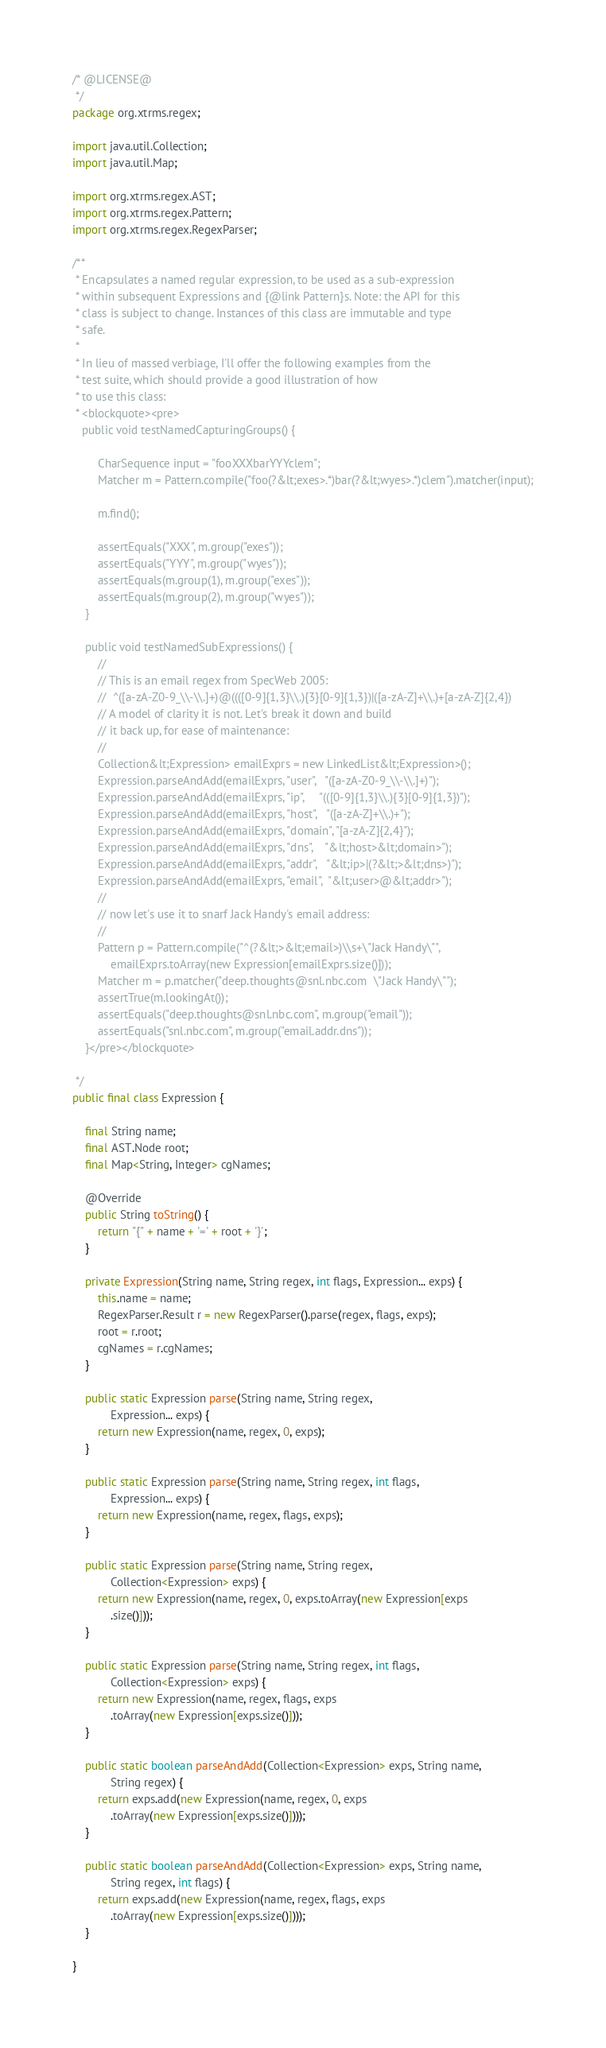Convert code to text. <code><loc_0><loc_0><loc_500><loc_500><_Java_>/* @LICENSE@  
 */
package org.xtrms.regex;

import java.util.Collection;
import java.util.Map;

import org.xtrms.regex.AST;
import org.xtrms.regex.Pattern;
import org.xtrms.regex.RegexParser;

/**
 * Encapsulates a named regular expression, to be used as a sub-expression
 * within subsequent Expressions and {@link Pattern}s. Note: the API for this
 * class is subject to change. Instances of this class are immutable and type
 * safe.
 * 
 * In lieu of massed verbiage, I'll offer the following examples from the 
 * test suite, which should provide a good illustration of how
 * to use this class:
 * <blockquote><pre>
   public void testNamedCapturingGroups() {
        
        CharSequence input = "fooXXXbarYYYclem";
        Matcher m = Pattern.compile("foo(?&lt;exes>.*)bar(?&lt;wyes>.*)clem").matcher(input);
        
        m.find();
        
        assertEquals("XXX", m.group("exes"));
        assertEquals("YYY", m.group("wyes"));
        assertEquals(m.group(1), m.group("exes"));
        assertEquals(m.group(2), m.group("wyes"));
    }
    
    public void testNamedSubExpressions() {
        //
        // This is an email regex from SpecWeb 2005:
        //  ^([a-zA-Z0-9_\\-\\.]+)@((([0-9]{1,3}\\.){3}[0-9]{1,3})|([a-zA-Z]+\\.)+[a-zA-Z]{2,4})
        // A model of clarity it is not. Let's break it down and build
        // it back up, for ease of maintenance:
        //
        Collection&lt;Expression> emailExprs = new LinkedList&lt;Expression>();
        Expression.parseAndAdd(emailExprs, "user",   "([a-zA-Z0-9_\\-\\.]+)");
        Expression.parseAndAdd(emailExprs, "ip",     "(([0-9]{1,3}\\.){3}[0-9]{1,3})");
        Expression.parseAndAdd(emailExprs, "host",   "([a-zA-Z]+\\.)+");
        Expression.parseAndAdd(emailExprs, "domain", "[a-zA-Z]{2,4}");
        Expression.parseAndAdd(emailExprs, "dns",    "&lt;host>&lt;domain>");
        Expression.parseAndAdd(emailExprs, "addr",   "&lt;ip>|(?&lt;>&lt;dns>)");
        Expression.parseAndAdd(emailExprs, "email",  "&lt;user>@&lt;addr>");
        //
        // now let's use it to snarf Jack Handy's email address:
        //
        Pattern p = Pattern.compile("^(?&lt;>&lt;email>)\\s+\"Jack Handy\"", 
            emailExprs.toArray(new Expression[emailExprs.size()]));
        Matcher m = p.matcher("deep.thoughts@snl.nbc.com  \"Jack Handy\"");
        assertTrue(m.lookingAt());
        assertEquals("deep.thoughts@snl.nbc.com", m.group("email"));
        assertEquals("snl.nbc.com", m.group("email.addr.dns"));
    }</pre></blockquote>
     
 */
public final class Expression {

    final String name;
    final AST.Node root;
    final Map<String, Integer> cgNames;
    
    @Override
    public String toString() {
        return "{" + name + '=' + root + '}';
    }

    private Expression(String name, String regex, int flags, Expression... exps) {
        this.name = name;
        RegexParser.Result r = new RegexParser().parse(regex, flags, exps);
        root = r.root;
        cgNames = r.cgNames;
    }

    public static Expression parse(String name, String regex,
            Expression... exps) {
        return new Expression(name, regex, 0, exps);
    }

    public static Expression parse(String name, String regex, int flags,
            Expression... exps) {
        return new Expression(name, regex, flags, exps);
    }

    public static Expression parse(String name, String regex,
            Collection<Expression> exps) {
        return new Expression(name, regex, 0, exps.toArray(new Expression[exps
            .size()]));
    }

    public static Expression parse(String name, String regex, int flags,
            Collection<Expression> exps) {
        return new Expression(name, regex, flags, exps
            .toArray(new Expression[exps.size()]));
    }

    public static boolean parseAndAdd(Collection<Expression> exps, String name,
            String regex) {
        return exps.add(new Expression(name, regex, 0, exps
            .toArray(new Expression[exps.size()])));
    }

    public static boolean parseAndAdd(Collection<Expression> exps, String name,
            String regex, int flags) {
        return exps.add(new Expression(name, regex, flags, exps
            .toArray(new Expression[exps.size()])));
    }

}
</code> 